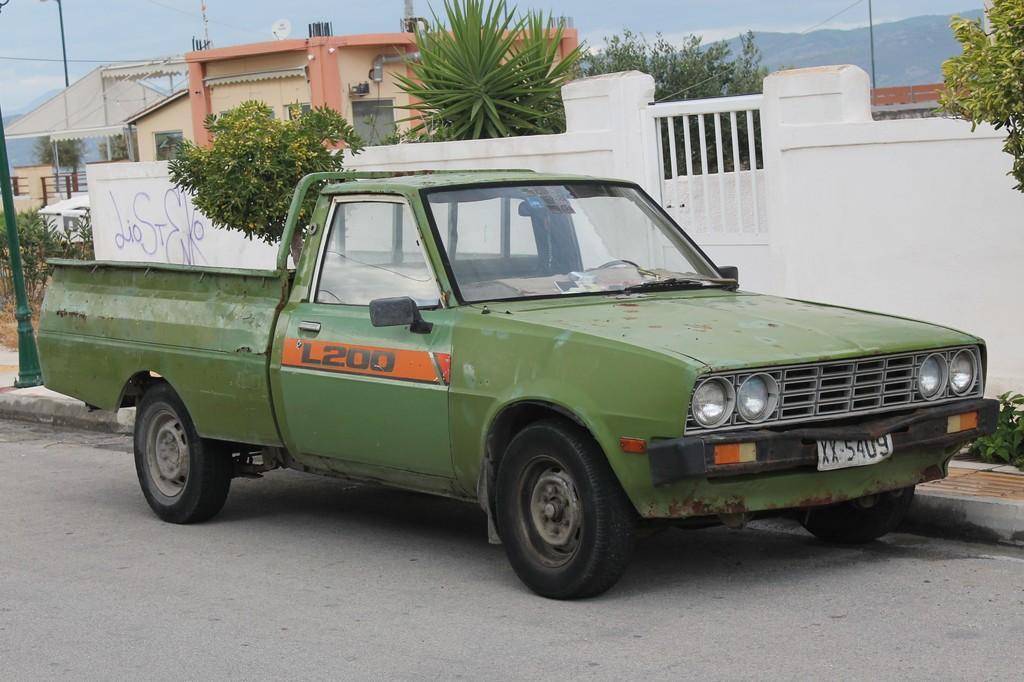Describe this image in one or two sentences. In the foreground of the picture, there is a truck side to a road. Behind it, there is a white wall, few trees and plants. On the left, there is a green color pole. In the background, there are few buildings, trees, mountains and the sky. 